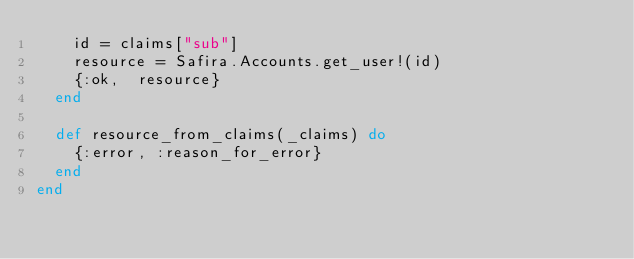<code> <loc_0><loc_0><loc_500><loc_500><_Elixir_>    id = claims["sub"]
    resource = Safira.Accounts.get_user!(id)
    {:ok,  resource}
  end

  def resource_from_claims(_claims) do
    {:error, :reason_for_error}
  end
end
</code> 